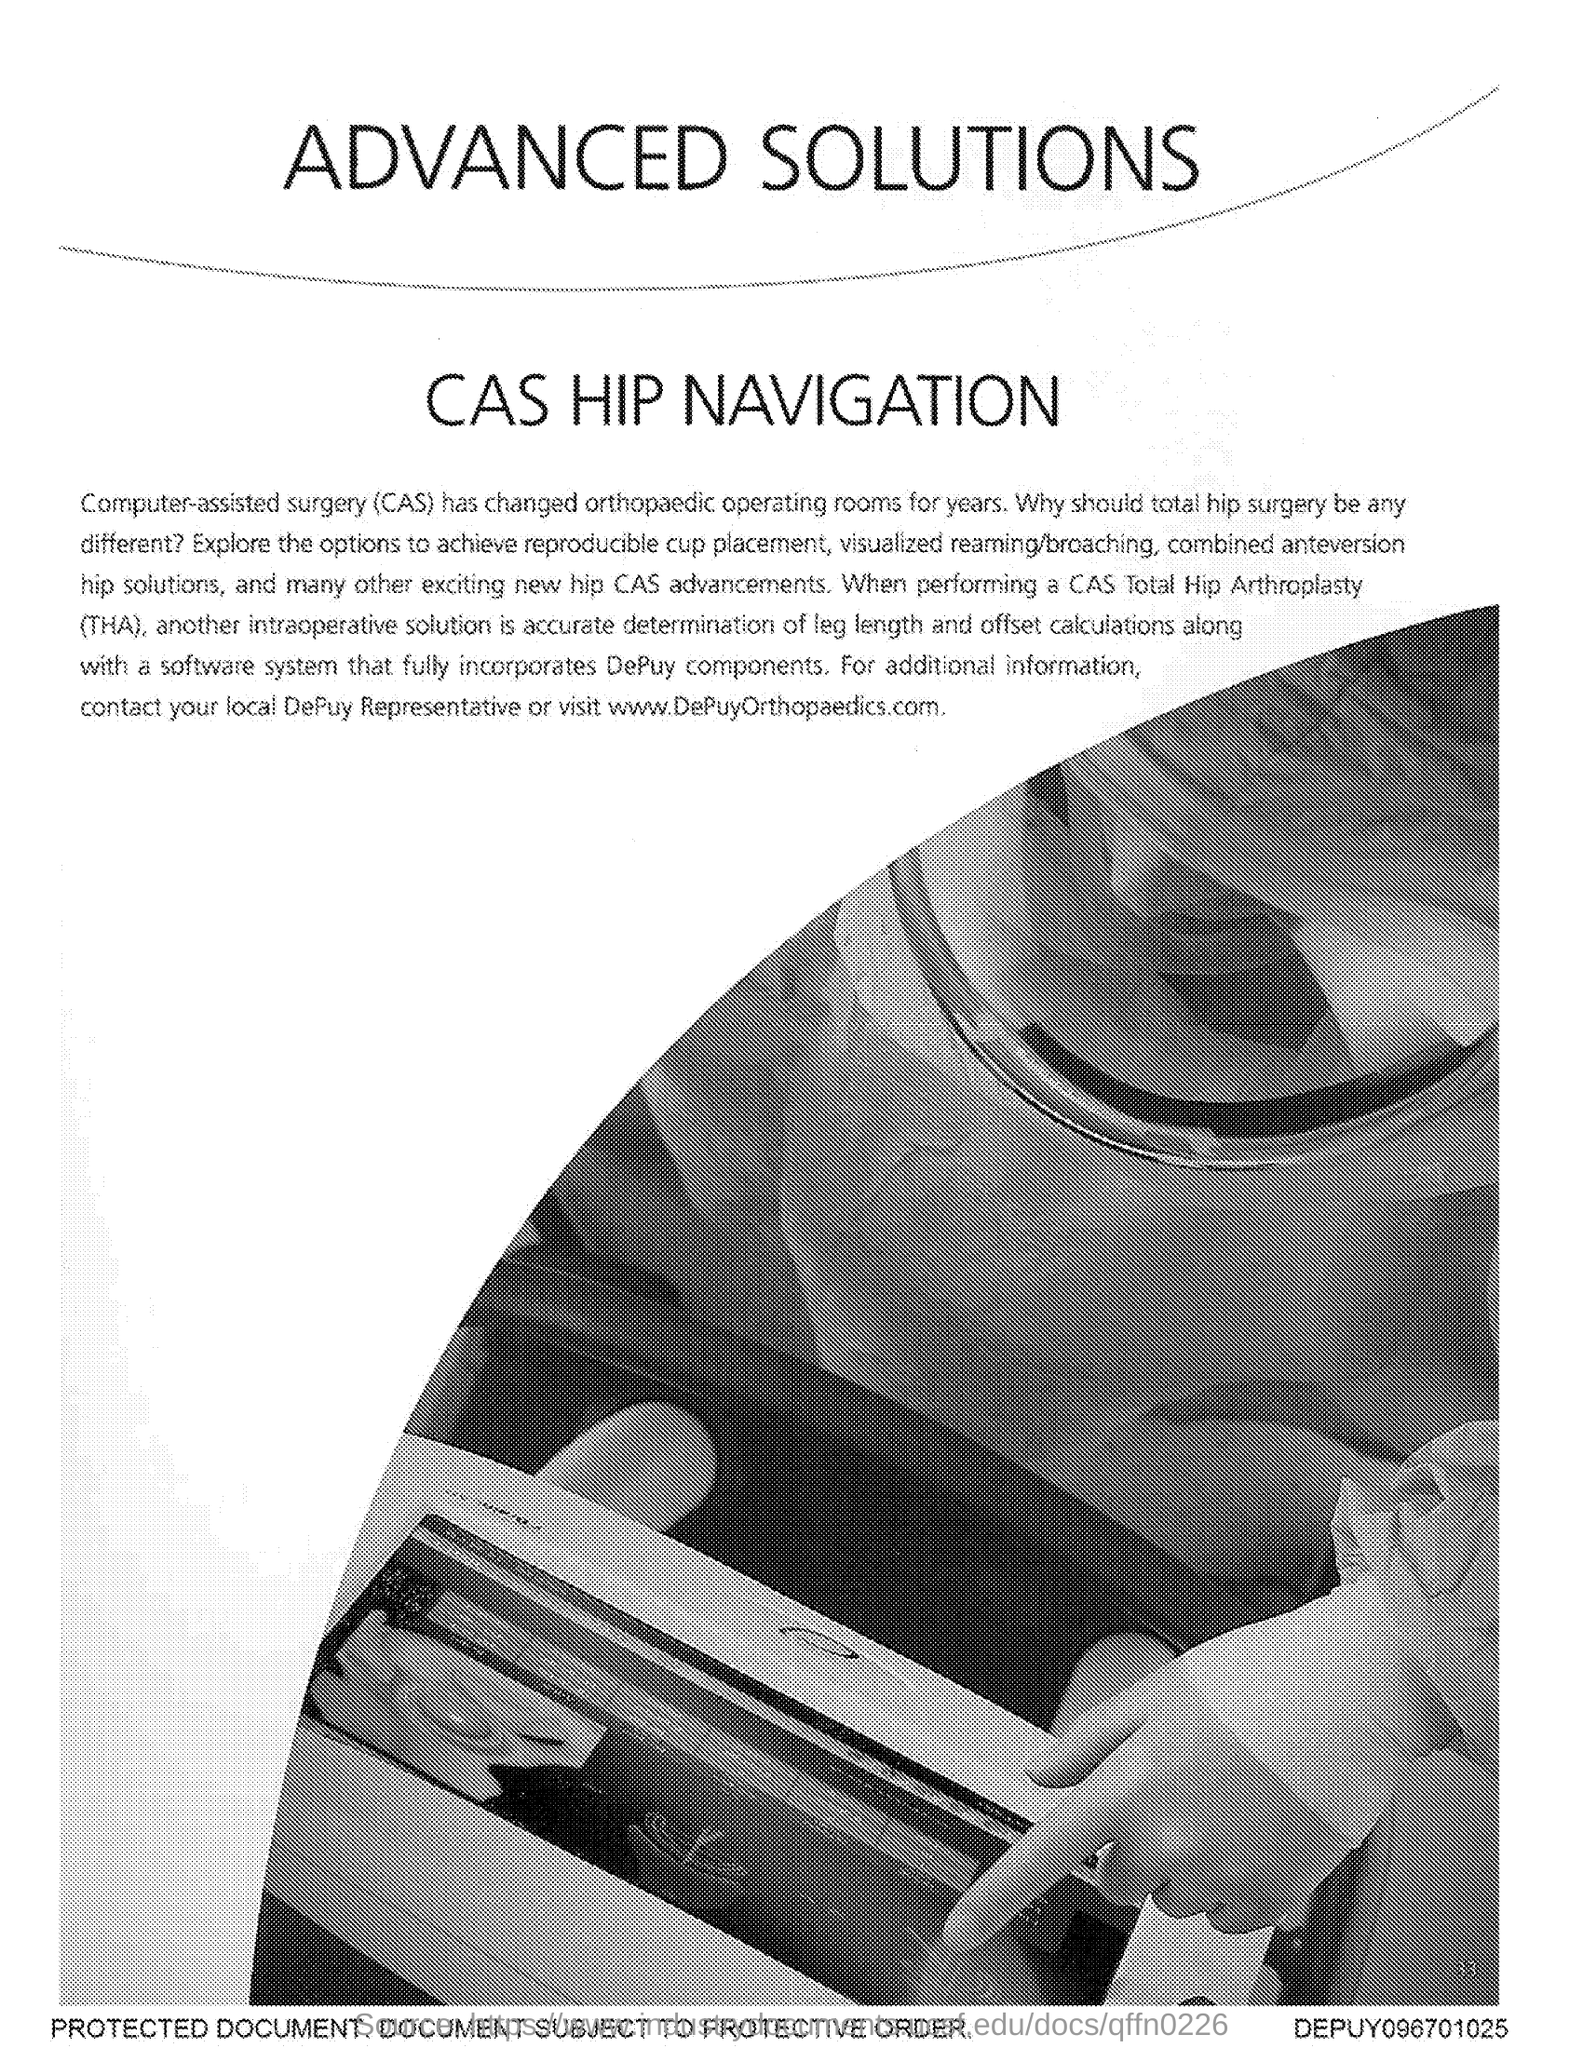Specify some key components in this picture. Total Hip Arthroplasty (THA) is a surgical procedure to replace the damaged or diseased hip joint with an artificial one. CAS stands for computer-assisted surgery, a technology that utilizes computers to enhance and assist in surgical procedures. 